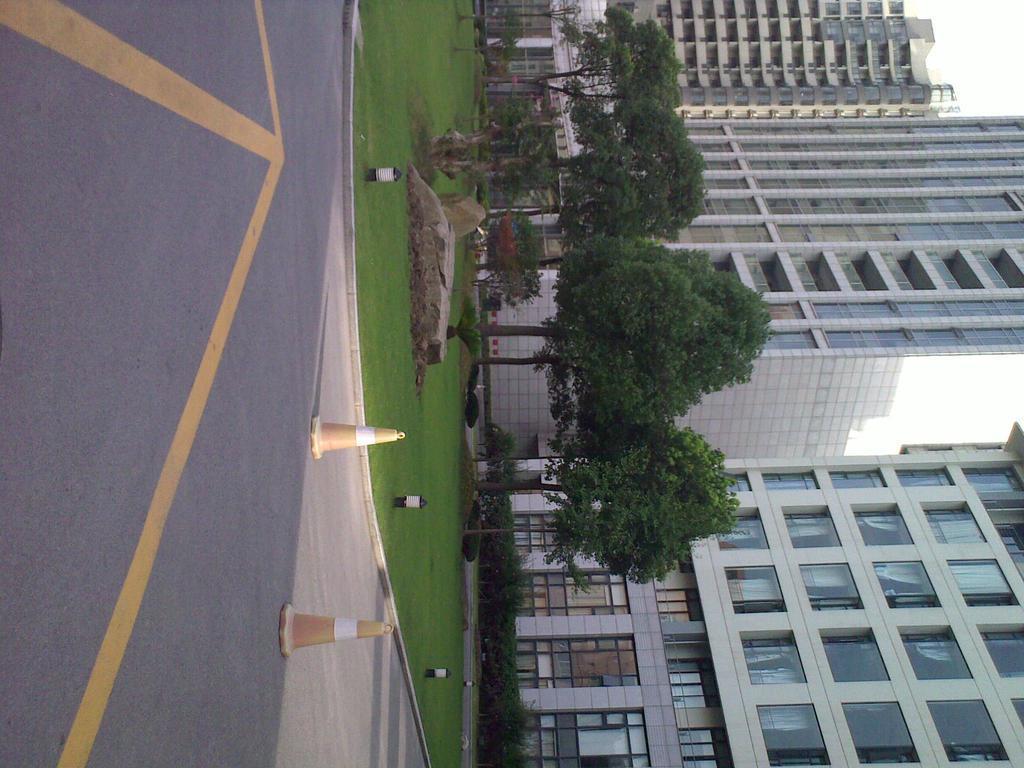How would you summarize this image in a sentence or two? Here in this picture we can see buildings with number of windows present over a place and we can see some part of ground is covered with grass and in the middle we can see rock stones present and we can also see plants and trees present on the ground and in the front we can see traffic signal cones present on the road. 